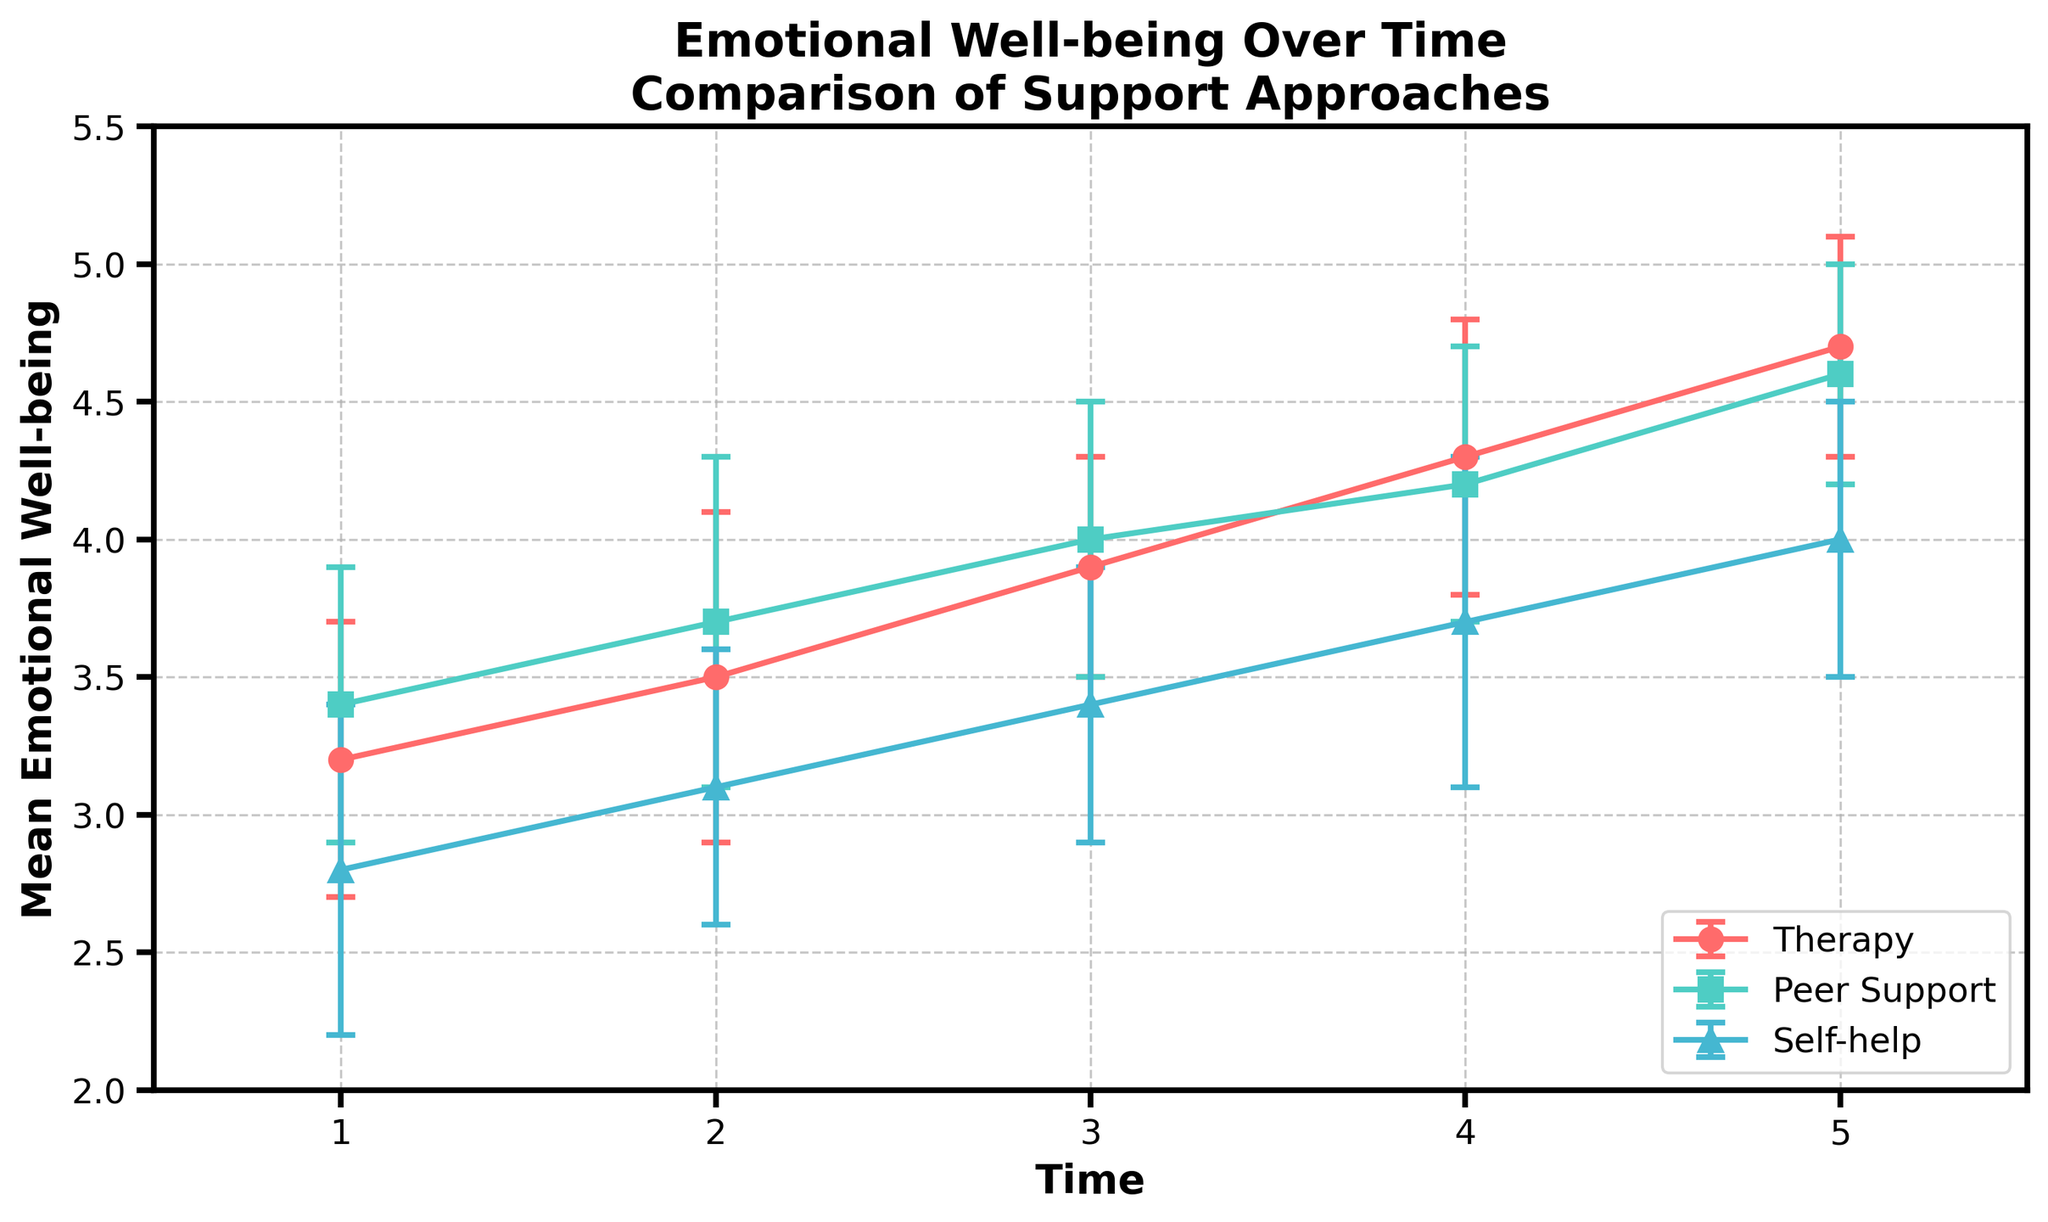Which support approach has the highest mean emotional well-being at Time 1? At Time 1, the mean emotional well-being for Therapy is 3.2, for Peer Support is 3.4, and for Self-help is 2.8. Peer Support has the highest value of 3.4.
Answer: Peer Support How does the mean emotional well-being change from Time 1 to Time 5 for Therapy? The mean emotional well-being for Therapy increases from 3.2 at Time 1 to 4.7 at Time 5, showing an increasing trend over time.
Answer: Increases At which time point does Self-help catch up with Peer Support in terms of mean emotional well-being? Self-help starts at 2.8 and Peer Support at 3.4. By Time 5, Self-help reaches 4.0 while Peer Support is at 4.6, but both increase steadily. Self-help doesn't catch up with Peer Support in the given time points.
Answer: Never catches up Comparing the standard deviation of emotional well-being at Time 3, which support approach has the smallest variability? At Time 3, the standard deviations are: Therapy: 0.4, Peer Support: 0.5, Self-help: 0.5. Therapy has the smallest variability with a standard deviation of 0.4.
Answer: Therapy What is the overall trend in emotional well-being for individuals in Therapy over the 5 time points? The trend line for Therapy shows a consistent increase in mean emotional well-being from 3.2 at Time 1 to 4.7 at Time 5.
Answer: Consistent increase Which support approach shows the greatest improvement in mean emotional well-being from Time 1 to Time 5? Improvements are: Therapy: 4.7 - 3.2 = 1.5, Peer Support: 4.6 - 3.4 = 1.2, Self-help: 4.0 - 2.8 = 1.2. Therapy has the greatest improvement of 1.5.
Answer: Therapy By how much does the mean emotional well-being increase from Time 2 to Time 4 for Peer Support? At Time 2, Peer Support's mean is 3.7 and at Time 4 it's 4.2. The increase is 4.2 - 3.7 = 0.5.
Answer: 0.5 Which support approach has the largest standard deviation at any time point? The highest standard deviation value seen in the data is 0.6, occurring for Therapy at Time 2, Peer Support at Time 2, and Self-help at Time 1 and Time 4.
Answer: Several approaches How does the trend for Self-help differ from the trends for Therapy and Peer Support? While Therapy and Peer Support show higher starting points and steady increases, Self-help starts lower and also increases but remains lower than the other two approaches throughout the time periods.
Answer: Starts lower, increases, remains lower 